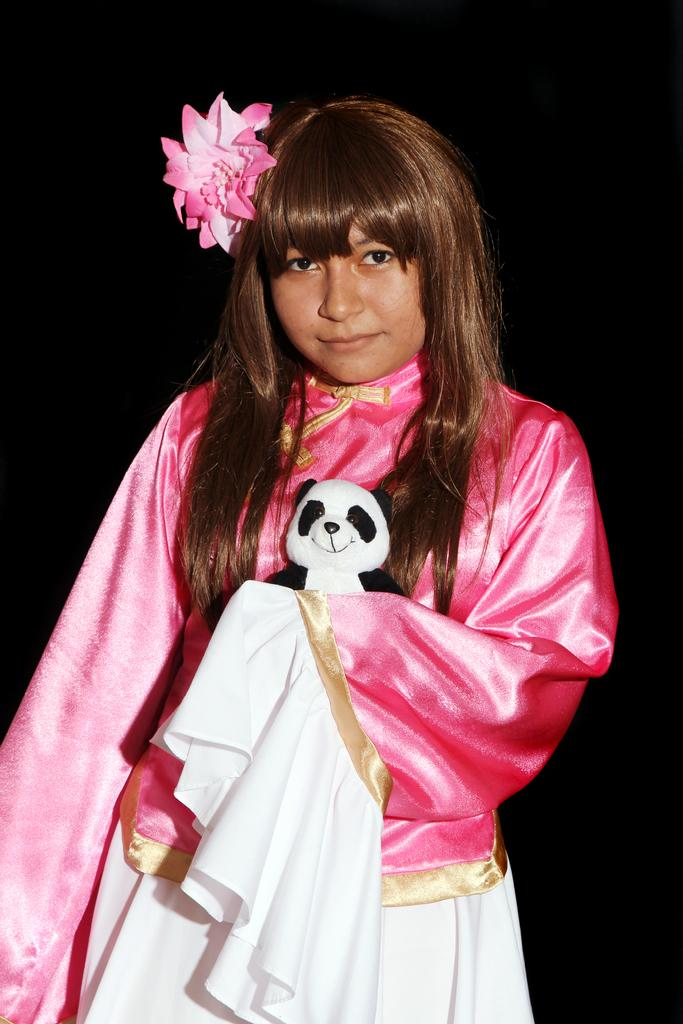Who is present in the image? There is a lady in the image. What is the lady holding in the image? The lady is holding a toy. Can you describe any other objects or elements in the image? There is a flower in the image. What type of stick can be seen in the lady's hand in the image? There is no stick present in the lady's hand or in the image. 